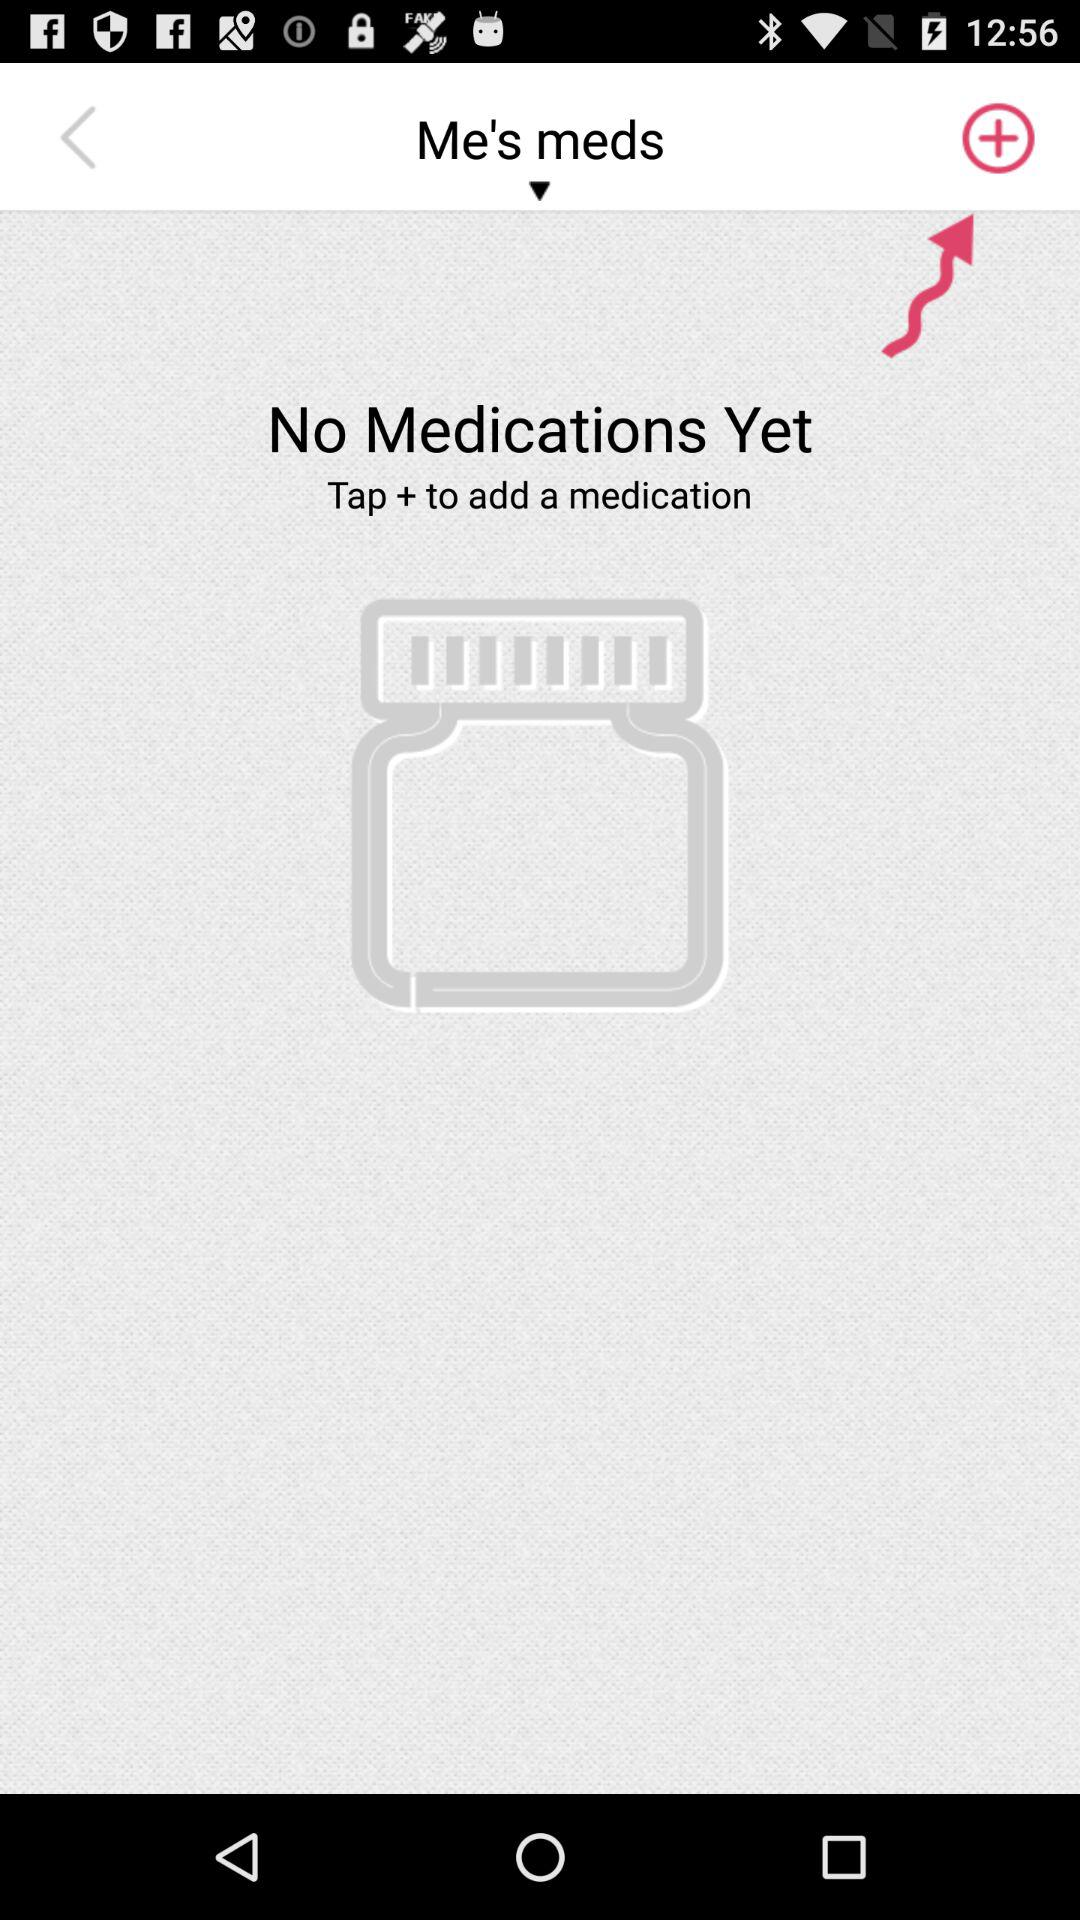How many medications do I have?
Answer the question using a single word or phrase. 0 